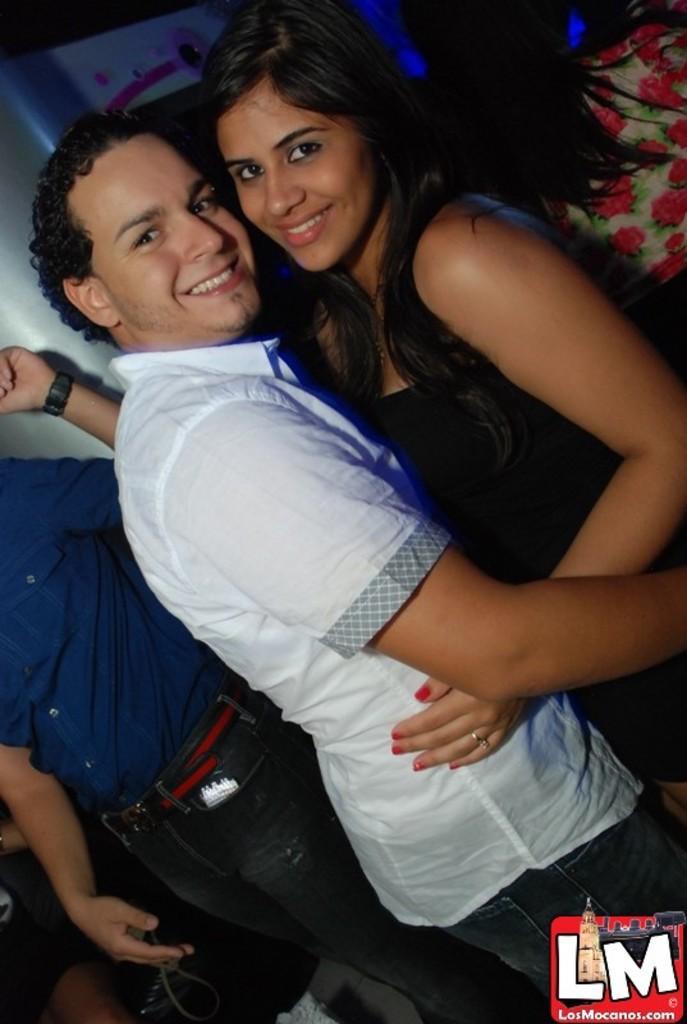Describe this image in one or two sentences. This image consists of so many persons. In the front there are two persons. One is man, another one is a woman. The woman is wearing a black dress, man is wearing a white dress. They are holding each other. 